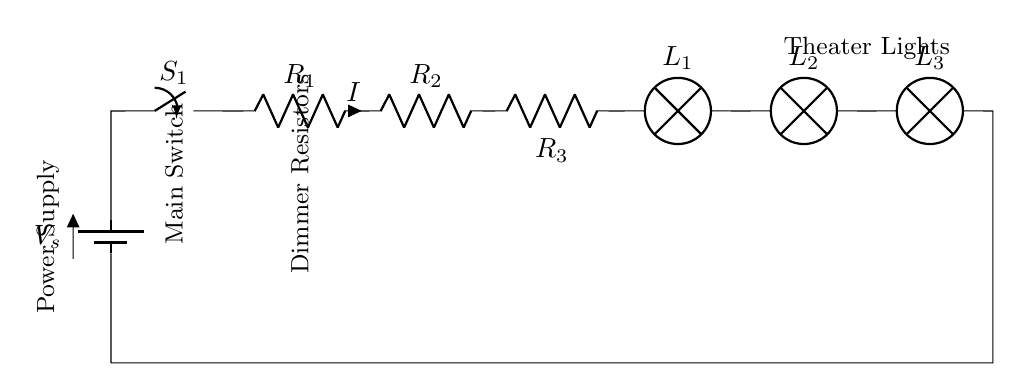What is the power supply in this circuit? The power supply indicated is labeled as V_s, which represents the voltage source providing energy to the circuit.
Answer: V_s What types of components are used for dimming lights? The circuit uses resistors R_1, R_2, and R_3, which are connected in series to control the current and adjust the brightness of the theater lights.
Answer: Resistors How many theater lights are represented in the circuit? The diagram shows three lamps labeled L_1, L_2, and L_3, indicating the presence of three theater lights connected in series.
Answer: Three What happens if the switch S_1 is open? If S_1 is open, the circuit is incomplete, preventing current from flowing, which means no light will be emitted by the lamps.
Answer: No light What current flows through the circuit? The current I flows through all components in the circuit and is dependent on the voltage source and total resistance but is indicated generically as "I" in the diagram.
Answer: I What is the arrangement of the lamps? The lamps L_1, L_2, and L_3 are in series, meaning each lamp receives the same current flowing through them without any parallel connections.
Answer: Series 